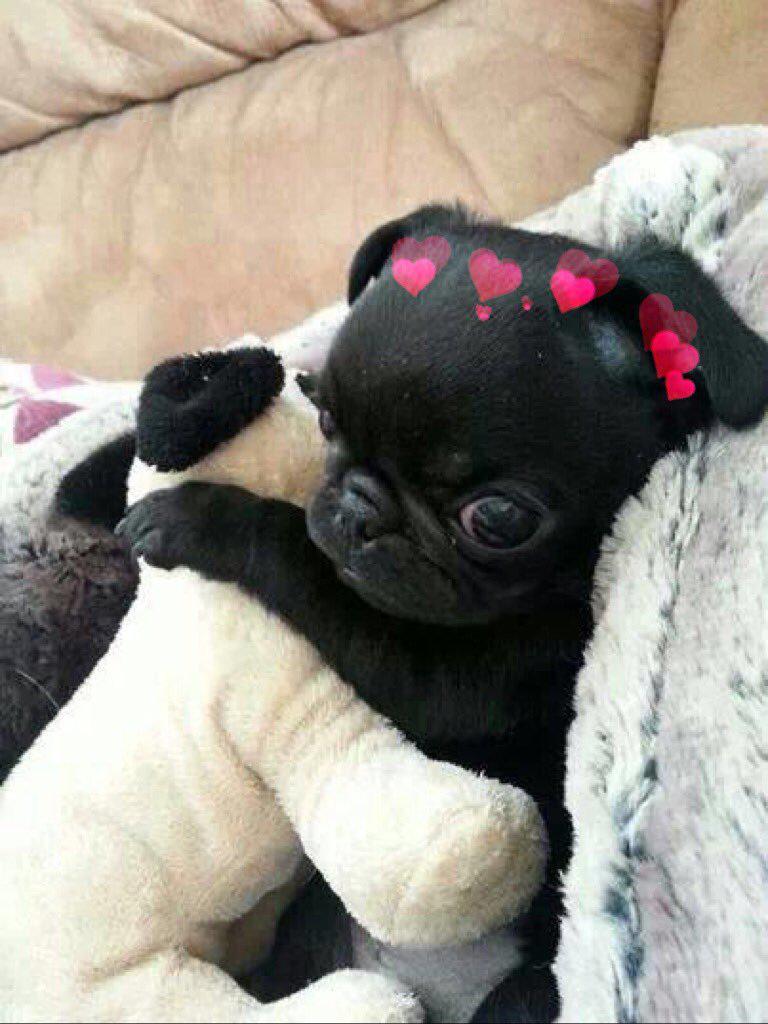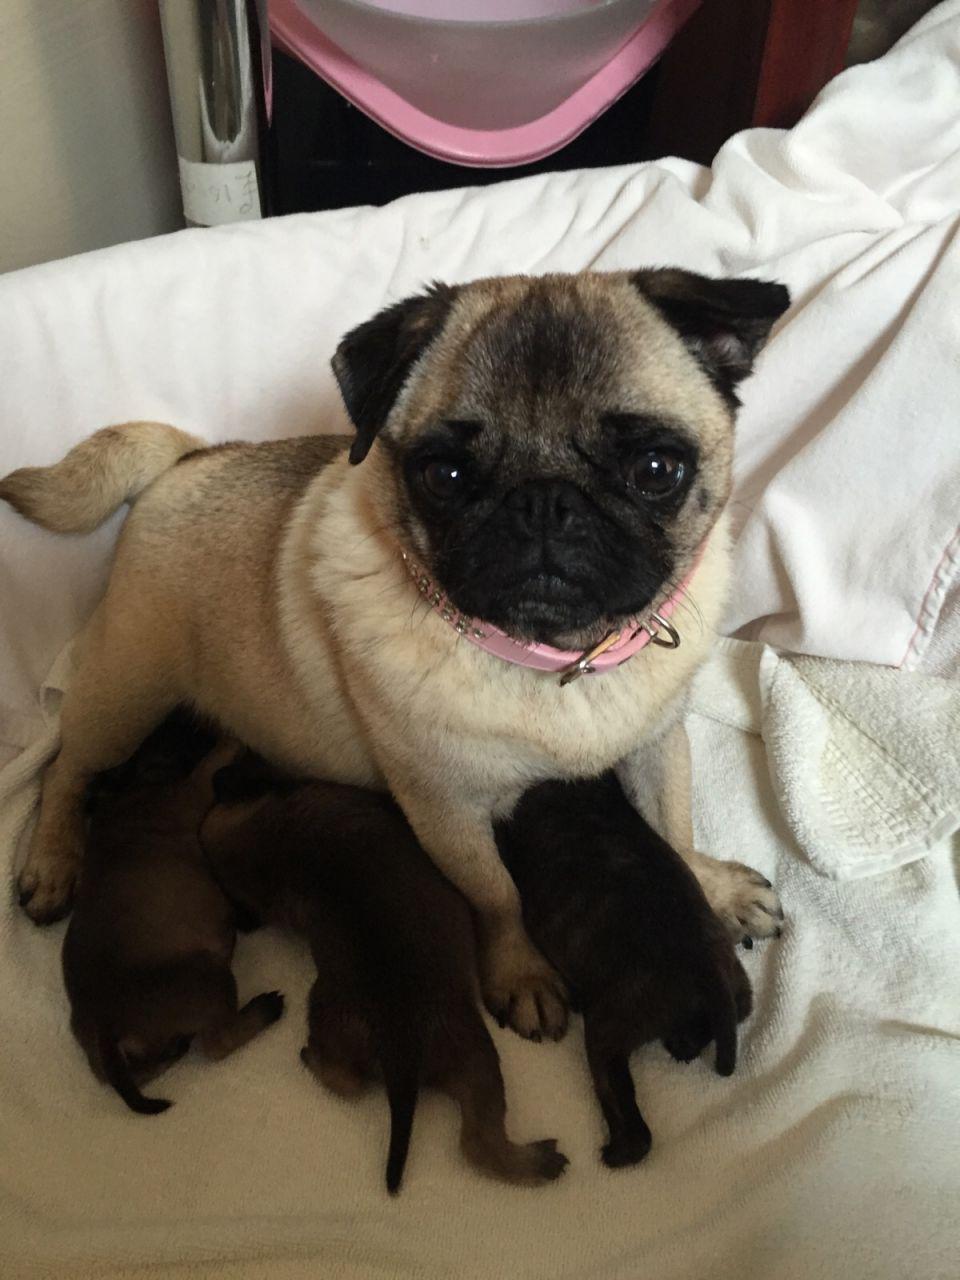The first image is the image on the left, the second image is the image on the right. For the images shown, is this caption "There is more than one dog in the right image." true? Answer yes or no. Yes. The first image is the image on the left, the second image is the image on the right. Examine the images to the left and right. Is the description "Each image contains exactly one dog, and each has black and white markings." accurate? Answer yes or no. No. 